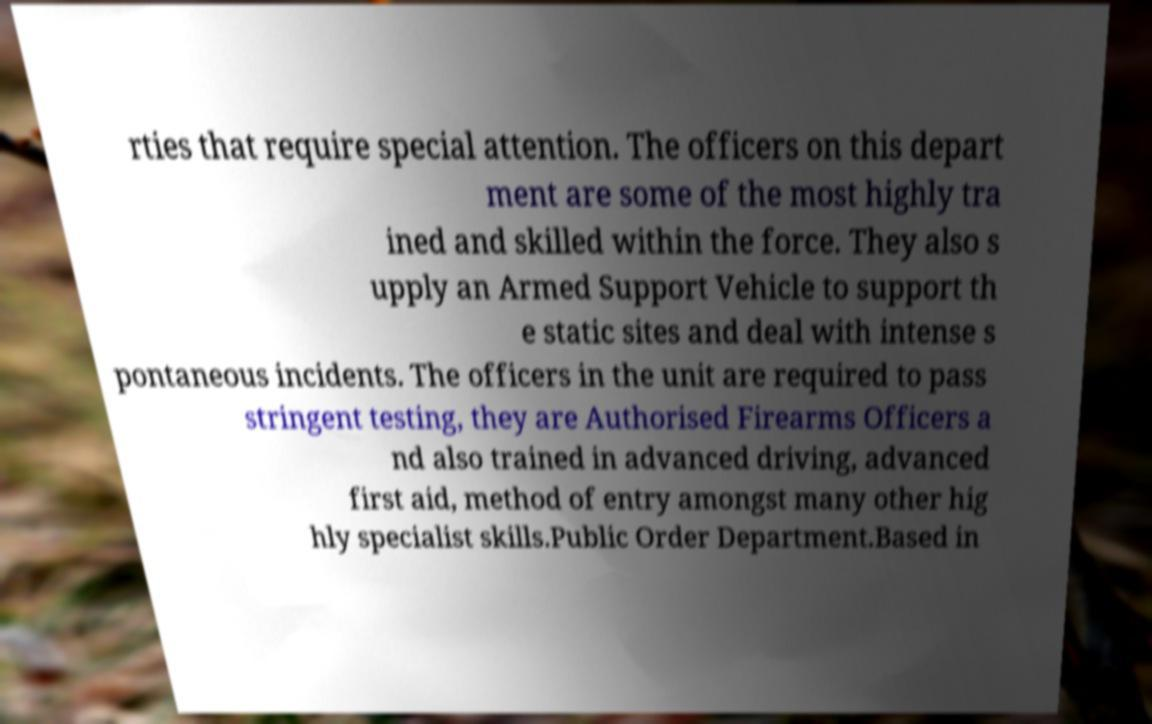Please identify and transcribe the text found in this image. rties that require special attention. The officers on this depart ment are some of the most highly tra ined and skilled within the force. They also s upply an Armed Support Vehicle to support th e static sites and deal with intense s pontaneous incidents. The officers in the unit are required to pass stringent testing, they are Authorised Firearms Officers a nd also trained in advanced driving, advanced first aid, method of entry amongst many other hig hly specialist skills.Public Order Department.Based in 